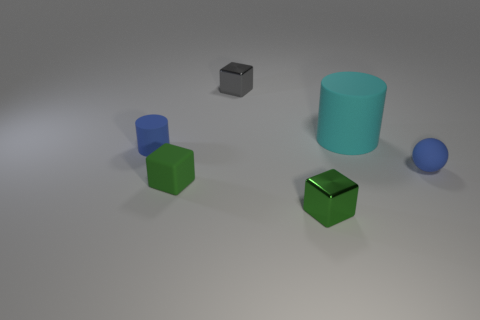The sphere that is the same color as the tiny matte cylinder is what size?
Offer a terse response. Small. What number of things are either small green matte spheres or rubber cylinders that are on the left side of the gray metal cube?
Offer a very short reply. 1. There is a small blue matte thing that is to the left of the small rubber cube; are there any tiny things that are behind it?
Your response must be concise. Yes. What shape is the blue thing that is to the right of the shiny cube that is in front of the blue matte object that is left of the blue ball?
Ensure brevity in your answer.  Sphere. There is a rubber object that is both right of the green metal object and behind the blue sphere; what color is it?
Your answer should be very brief. Cyan. There is a shiny object behind the cyan cylinder; what shape is it?
Your answer should be compact. Cube. The small blue thing that is made of the same material as the tiny blue sphere is what shape?
Provide a succinct answer. Cylinder. How many metallic objects are tiny cylinders or tiny purple spheres?
Ensure brevity in your answer.  0. What number of cyan matte cylinders are behind the blue matte object that is behind the tiny blue object that is on the right side of the blue matte cylinder?
Make the answer very short. 1. There is a blue rubber thing that is behind the blue rubber ball; does it have the same size as the blue object in front of the small matte cylinder?
Ensure brevity in your answer.  Yes. 